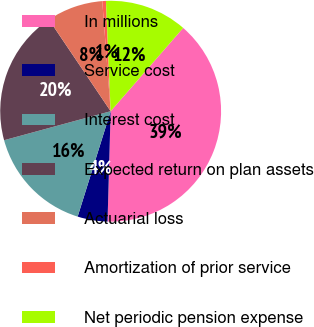Convert chart. <chart><loc_0><loc_0><loc_500><loc_500><pie_chart><fcel>In millions<fcel>Service cost<fcel>Interest cost<fcel>Expected return on plan assets<fcel>Actuarial loss<fcel>Amortization of prior service<fcel>Net periodic pension expense<nl><fcel>39.05%<fcel>4.38%<fcel>15.94%<fcel>19.79%<fcel>8.23%<fcel>0.53%<fcel>12.08%<nl></chart> 